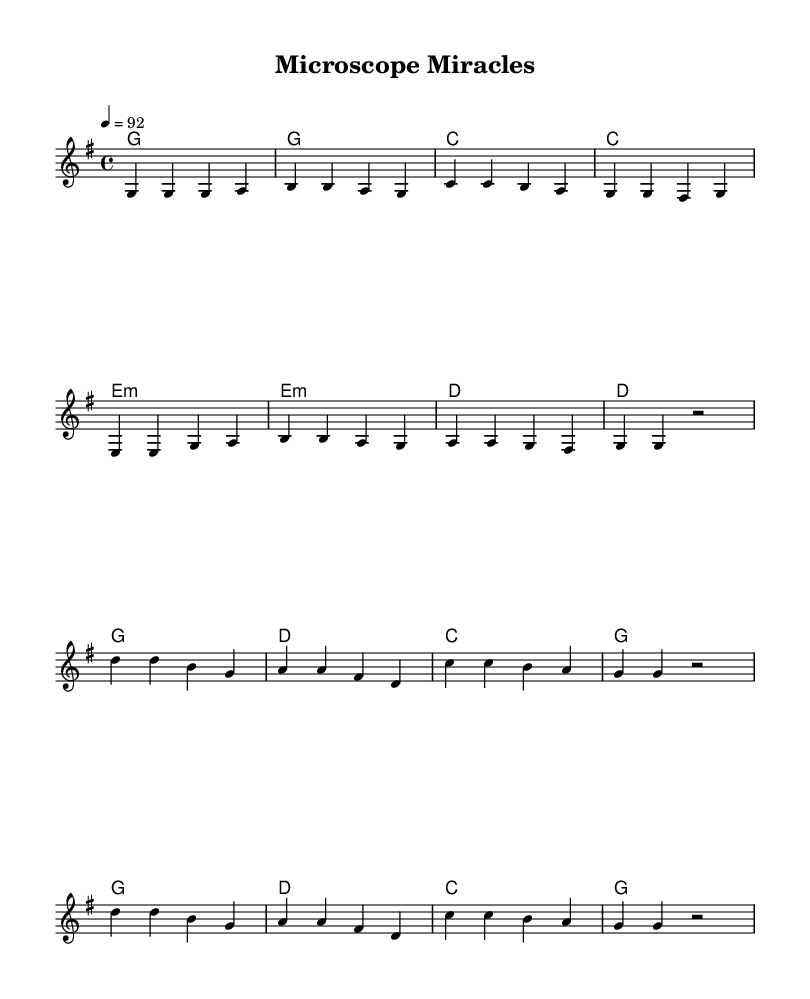What is the key signature of this music? The key signature is G major, which has one sharp (F#). This can be identified at the beginning of the score, where the key signature is written.
Answer: G major What is the time signature of the piece? The time signature is 4/4, meaning there are four beats in each measure and the quarter note receives one beat. This is indicated right after the key signature at the beginning of the score.
Answer: 4/4 What is the tempo marking of this song? The tempo marking is 92, indicating that the piece should be played at 92 beats per minute. This marking is provided after the time signature in the global settings.
Answer: 92 How many chords are in the verse section? The verse section includes a total of 8 chords, as noted in the chord mode section of the score where each chord is listed out for every measure in the verse.
Answer: 8 What type of lyrics are featured in this song? The lyrics of this song are narrative and relate to scientific breakthroughs and medical advancements, characterized by a storytelling style typical in country music. This can be inferred from the themes present in the verse and chorus without formal music notation.
Answer: Narrative What is the structure of the song? The structure consists of verses followed by a chorus, which is a common form in country music. Analyzing the layout of the score reveals the repeating sequence with distinct sections labeled for verses and choruses.
Answer: Verse-Chorus How many measures are in the chorus section? The chorus consists of 8 measures, as each line of the chorus contains a specific number of notes corresponding to musical measures indicated by the chord changes and melody arrangements provided.
Answer: 8 